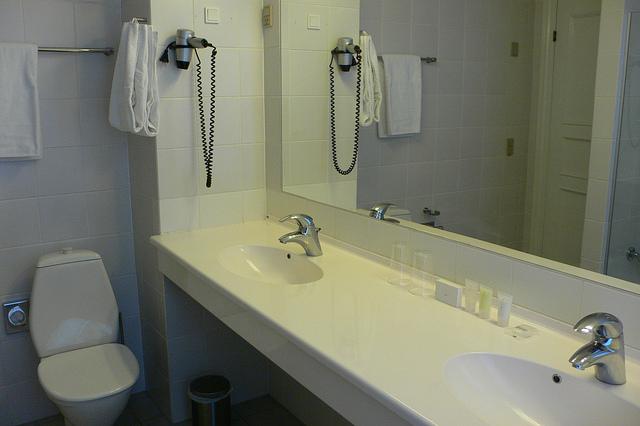What has a black cord?
Keep it brief. Hair dryer. How many sinks are visible?
Concise answer only. 2. Is this a hotel bathroom?
Concise answer only. Yes. What is the mirror for?
Short answer required. Reflection. 